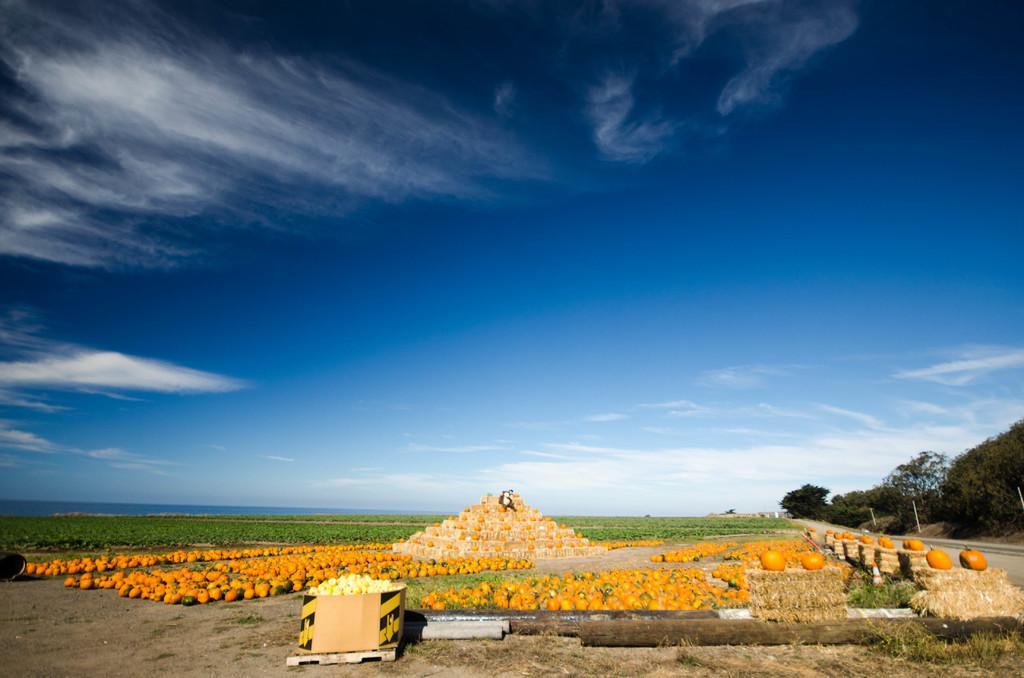Please provide a concise description of this image. In this image there are few pumpkins. On the land there is a box having few items in it. Beside there are few wooden trunks. On the grass bundles there are few pumpkins which are kept beside the road. Left side there are few plants. Right side there are few trees. Top of image there is sky with some clouds. 